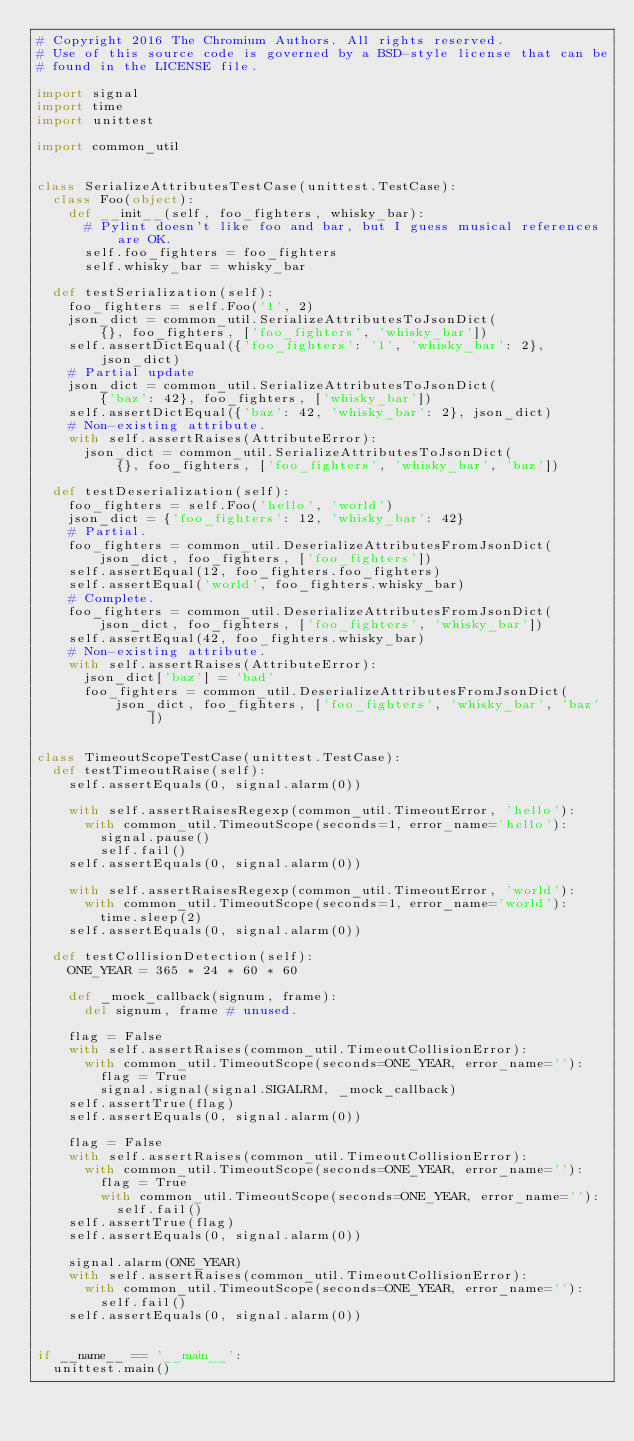Convert code to text. <code><loc_0><loc_0><loc_500><loc_500><_Python_># Copyright 2016 The Chromium Authors. All rights reserved.
# Use of this source code is governed by a BSD-style license that can be
# found in the LICENSE file.

import signal
import time
import unittest

import common_util


class SerializeAttributesTestCase(unittest.TestCase):
  class Foo(object):
    def __init__(self, foo_fighters, whisky_bar):
      # Pylint doesn't like foo and bar, but I guess musical references are OK.
      self.foo_fighters = foo_fighters
      self.whisky_bar = whisky_bar

  def testSerialization(self):
    foo_fighters = self.Foo('1', 2)
    json_dict = common_util.SerializeAttributesToJsonDict(
        {}, foo_fighters, ['foo_fighters', 'whisky_bar'])
    self.assertDictEqual({'foo_fighters': '1', 'whisky_bar': 2}, json_dict)
    # Partial update
    json_dict = common_util.SerializeAttributesToJsonDict(
        {'baz': 42}, foo_fighters, ['whisky_bar'])
    self.assertDictEqual({'baz': 42, 'whisky_bar': 2}, json_dict)
    # Non-existing attribute.
    with self.assertRaises(AttributeError):
      json_dict = common_util.SerializeAttributesToJsonDict(
          {}, foo_fighters, ['foo_fighters', 'whisky_bar', 'baz'])

  def testDeserialization(self):
    foo_fighters = self.Foo('hello', 'world')
    json_dict = {'foo_fighters': 12, 'whisky_bar': 42}
    # Partial.
    foo_fighters = common_util.DeserializeAttributesFromJsonDict(
        json_dict, foo_fighters, ['foo_fighters'])
    self.assertEqual(12, foo_fighters.foo_fighters)
    self.assertEqual('world', foo_fighters.whisky_bar)
    # Complete.
    foo_fighters = common_util.DeserializeAttributesFromJsonDict(
        json_dict, foo_fighters, ['foo_fighters', 'whisky_bar'])
    self.assertEqual(42, foo_fighters.whisky_bar)
    # Non-existing attribute.
    with self.assertRaises(AttributeError):
      json_dict['baz'] = 'bad'
      foo_fighters = common_util.DeserializeAttributesFromJsonDict(
          json_dict, foo_fighters, ['foo_fighters', 'whisky_bar', 'baz'])


class TimeoutScopeTestCase(unittest.TestCase):
  def testTimeoutRaise(self):
    self.assertEquals(0, signal.alarm(0))

    with self.assertRaisesRegexp(common_util.TimeoutError, 'hello'):
      with common_util.TimeoutScope(seconds=1, error_name='hello'):
        signal.pause()
        self.fail()
    self.assertEquals(0, signal.alarm(0))

    with self.assertRaisesRegexp(common_util.TimeoutError, 'world'):
      with common_util.TimeoutScope(seconds=1, error_name='world'):
        time.sleep(2)
    self.assertEquals(0, signal.alarm(0))

  def testCollisionDetection(self):
    ONE_YEAR = 365 * 24 * 60 * 60

    def _mock_callback(signum, frame):
      del signum, frame # unused.

    flag = False
    with self.assertRaises(common_util.TimeoutCollisionError):
      with common_util.TimeoutScope(seconds=ONE_YEAR, error_name=''):
        flag = True
        signal.signal(signal.SIGALRM, _mock_callback)
    self.assertTrue(flag)
    self.assertEquals(0, signal.alarm(0))

    flag = False
    with self.assertRaises(common_util.TimeoutCollisionError):
      with common_util.TimeoutScope(seconds=ONE_YEAR, error_name=''):
        flag = True
        with common_util.TimeoutScope(seconds=ONE_YEAR, error_name=''):
          self.fail()
    self.assertTrue(flag)
    self.assertEquals(0, signal.alarm(0))

    signal.alarm(ONE_YEAR)
    with self.assertRaises(common_util.TimeoutCollisionError):
      with common_util.TimeoutScope(seconds=ONE_YEAR, error_name=''):
        self.fail()
    self.assertEquals(0, signal.alarm(0))


if __name__ == '__main__':
  unittest.main()
</code> 